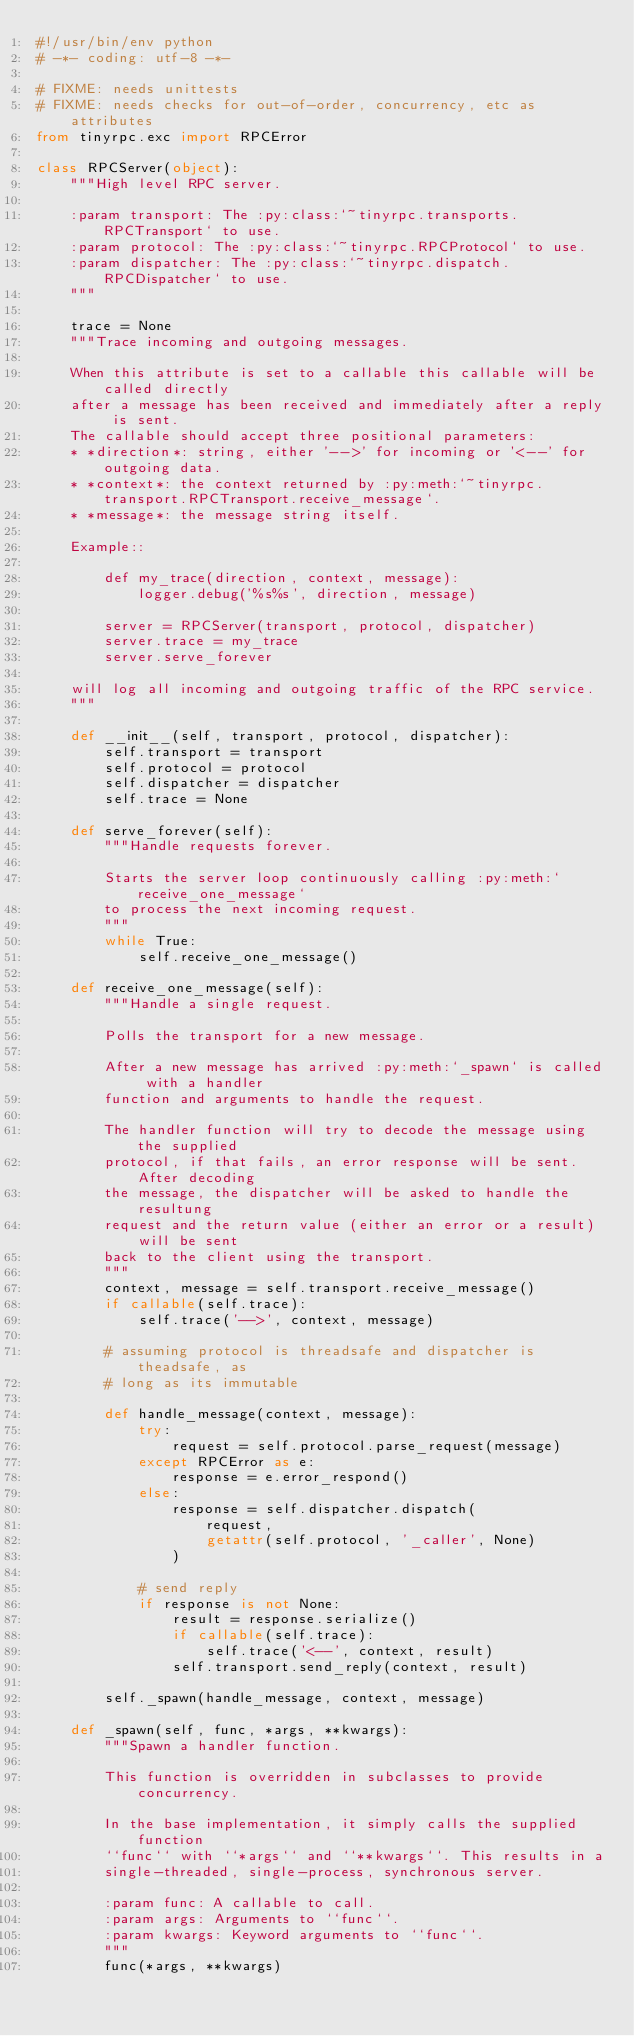Convert code to text. <code><loc_0><loc_0><loc_500><loc_500><_Python_>#!/usr/bin/env python
# -*- coding: utf-8 -*-

# FIXME: needs unittests
# FIXME: needs checks for out-of-order, concurrency, etc as attributes
from tinyrpc.exc import RPCError

class RPCServer(object):
    """High level RPC server.

    :param transport: The :py:class:`~tinyrpc.transports.RPCTransport` to use.
    :param protocol: The :py:class:`~tinyrpc.RPCProtocol` to use.
    :param dispatcher: The :py:class:`~tinyrpc.dispatch.RPCDispatcher` to use.
    """
    
    trace = None
    """Trace incoming and outgoing messages.
    
    When this attribute is set to a callable this callable will be called directly
    after a message has been received and immediately after a reply is sent.
    The callable should accept three positional parameters:
    * *direction*: string, either '-->' for incoming or '<--' for outgoing data.
    * *context*: the context returned by :py:meth:`~tinyrpc.transport.RPCTransport.receive_message`.
    * *message*: the message string itself.
    
    Example::
    
        def my_trace(direction, context, message):
            logger.debug('%s%s', direction, message)
        
        server = RPCServer(transport, protocol, dispatcher)
        server.trace = my_trace
        server.serve_forever
        
    will log all incoming and outgoing traffic of the RPC service.
    """
    
    def __init__(self, transport, protocol, dispatcher):
        self.transport = transport
        self.protocol = protocol
        self.dispatcher = dispatcher
        self.trace = None

    def serve_forever(self):
        """Handle requests forever.

        Starts the server loop continuously calling :py:meth:`receive_one_message`
        to process the next incoming request.
        """
        while True:
            self.receive_one_message()

    def receive_one_message(self):
        """Handle a single request.

        Polls the transport for a new message.
        
        After a new message has arrived :py:meth:`_spawn` is called with a handler
        function and arguments to handle the request.

        The handler function will try to decode the message using the supplied
        protocol, if that fails, an error response will be sent. After decoding
        the message, the dispatcher will be asked to handle the resultung
        request and the return value (either an error or a result) will be sent
        back to the client using the transport.
        """
        context, message = self.transport.receive_message()
        if callable(self.trace):
            self.trace('-->', context, message)
        
        # assuming protocol is threadsafe and dispatcher is theadsafe, as
        # long as its immutable

        def handle_message(context, message):
            try:
                request = self.protocol.parse_request(message)
            except RPCError as e:
                response = e.error_respond()
            else:
                response = self.dispatcher.dispatch(
                    request, 
                    getattr(self.protocol, '_caller', None)
                )

            # send reply
            if response is not None:
                result = response.serialize()
                if callable(self.trace):
                    self.trace('<--', context, result)
                self.transport.send_reply(context, result)

        self._spawn(handle_message, context, message)

    def _spawn(self, func, *args, **kwargs):
        """Spawn a handler function.

        This function is overridden in subclasses to provide concurrency.

        In the base implementation, it simply calls the supplied function
        ``func`` with ``*args`` and ``**kwargs``. This results in a
        single-threaded, single-process, synchronous server.

        :param func: A callable to call.
        :param args: Arguments to ``func``.
        :param kwargs: Keyword arguments to ``func``.
        """
        func(*args, **kwargs)
</code> 